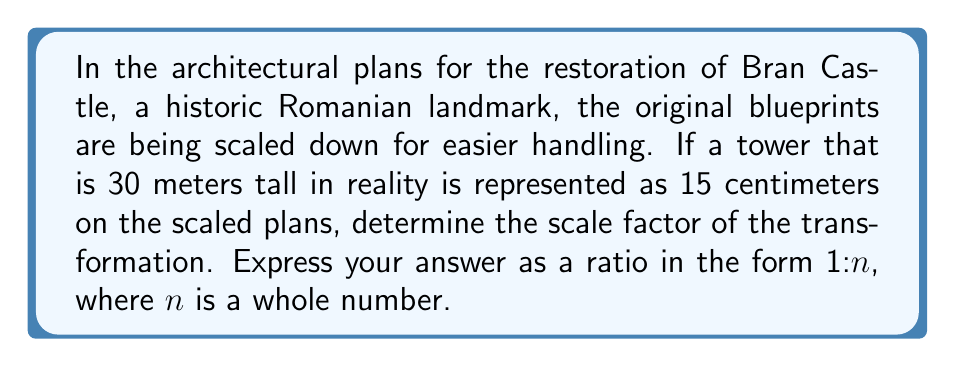Solve this math problem. To solve this problem, we need to follow these steps:

1) First, let's convert all measurements to the same unit. We'll use centimeters:
   30 meters = 3000 centimeters
   
2) Now, we can set up the ratio of the scaled dimension to the actual dimension:
   $$\frac{\text{scaled dimension}}{\text{actual dimension}} = \frac{15 \text{ cm}}{3000 \text{ cm}}$$

3) This ratio represents the scale factor. Let's simplify it:
   $$\frac{15}{3000} = \frac{1}{200}$$

4) This means that 1 unit on the plan represents 200 units in reality.

5) To express this as a ratio in the form 1:n, we simply write:
   1:200

This scale factor means that every 1 cm on the plan represents 200 cm (or 2 meters) in the actual castle.
Answer: 1:200 